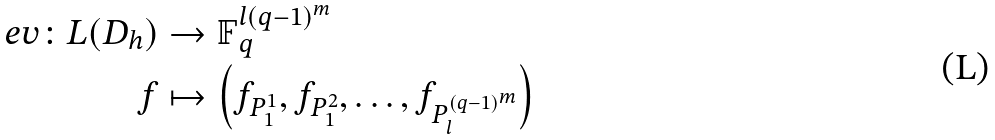<formula> <loc_0><loc_0><loc_500><loc_500>\ e v \colon L ( D _ { h } ) & \to \mathbb { F } _ { q } ^ { l ( q - 1 ) ^ { m } } \\ f & \mapsto \left ( f _ { P _ { 1 } ^ { 1 } } , f _ { P _ { 1 } ^ { 2 } } , \dots , f _ { P _ { l } ^ { ( q - 1 ) ^ { m } } } \right )</formula> 